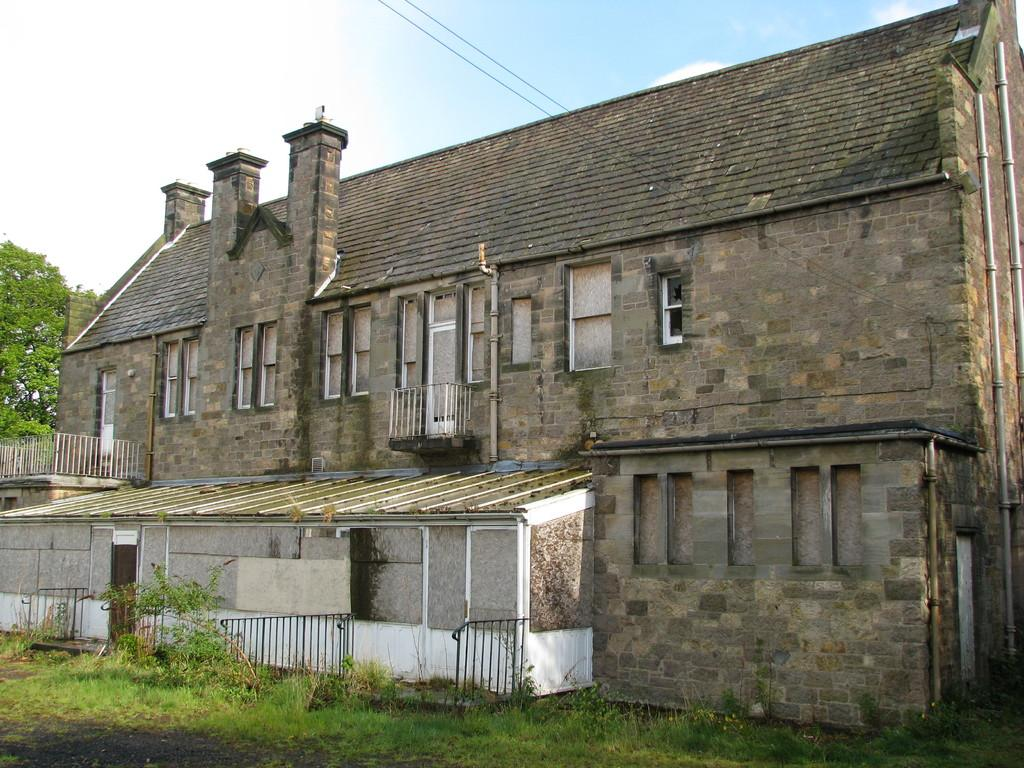What is the main structure in the picture? There is a building in the picture. What features can be observed on the building? The building has windows and doors. What type of surface is present on the floor? There is grass on the floor. What is visible on the left side of the image? There is a tree on the left side of the image. How would you describe the sky in the picture? The sky is clear in the picture. How much pollution is visible in the image? There is no visible pollution in the image; it features a clear sky and a natural environment. What type of addition problem can be solved using the numbers on the building? There are no numbers present on the building, so it is not possible to solve an addition problem based on the image. 